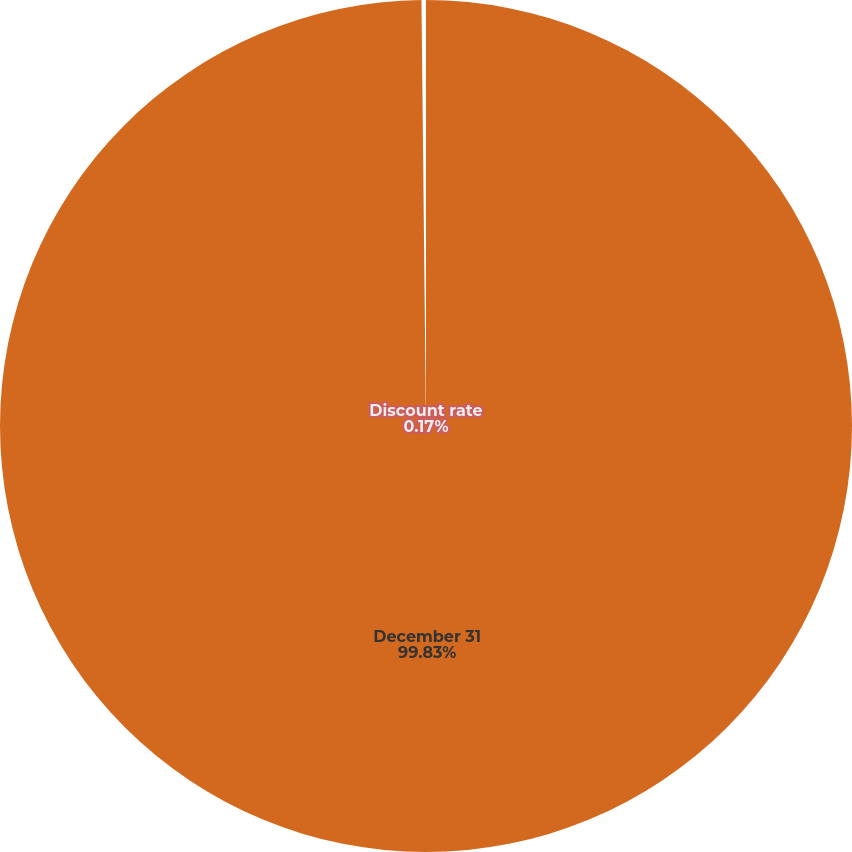Convert chart. <chart><loc_0><loc_0><loc_500><loc_500><pie_chart><fcel>December 31<fcel>Discount rate<nl><fcel>99.83%<fcel>0.17%<nl></chart> 